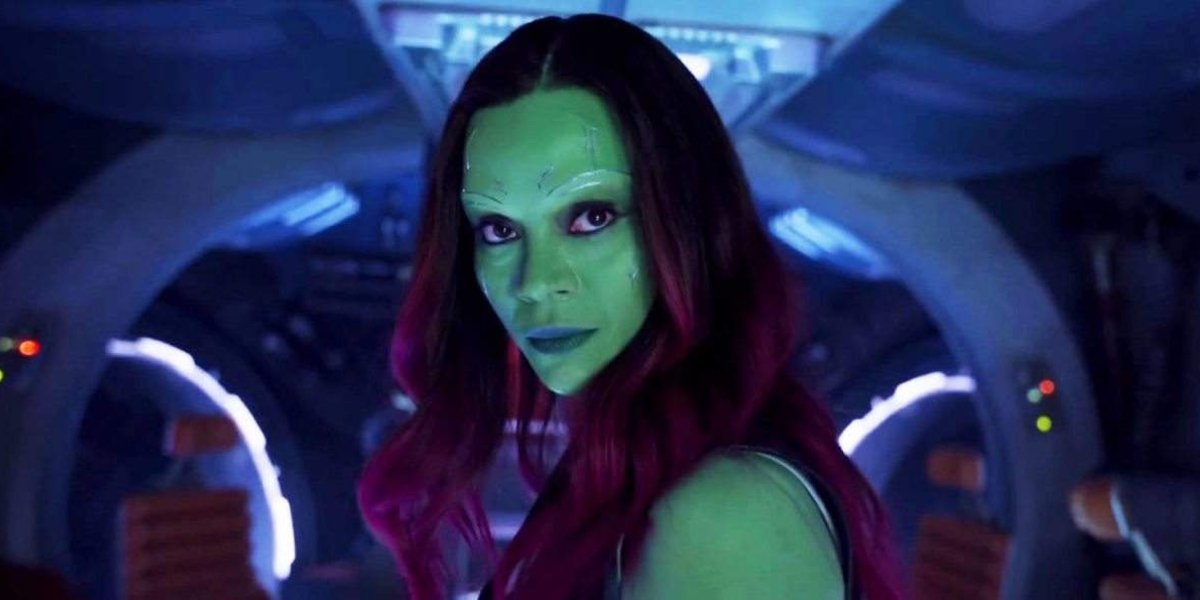Can you tell me what kind of emotions this character's expression conveys? The character exhibits a serious and determined demeanor. Her direct gaze and subtle tension in her features indicate focus and perhaps a readiness to confront a situation. The setting and her appearance hint at a narrative where resilience and strength play a key role. 